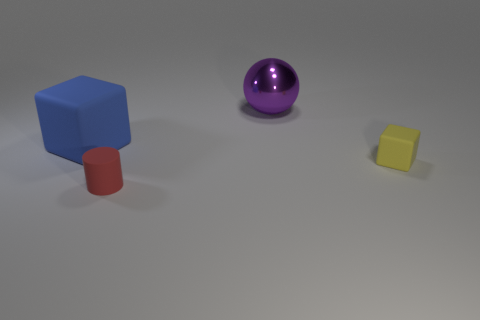Add 1 large rubber things. How many objects exist? 5 Subtract all cyan cylinders. Subtract all purple spheres. How many cylinders are left? 1 Subtract all balls. How many objects are left? 3 Subtract all large purple matte blocks. Subtract all yellow matte blocks. How many objects are left? 3 Add 1 red matte cylinders. How many red matte cylinders are left? 2 Add 3 large objects. How many large objects exist? 5 Subtract 0 blue cylinders. How many objects are left? 4 